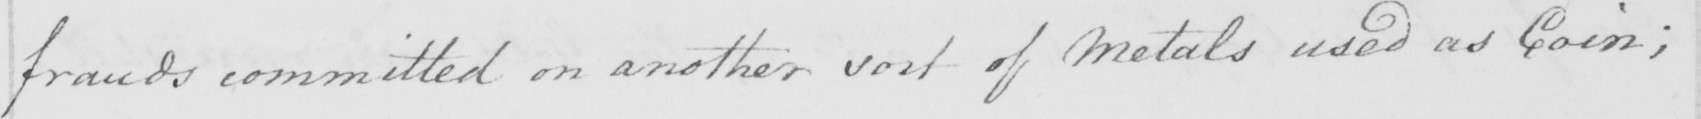Please transcribe the handwritten text in this image. frauds committed on another sort of Metals used as Coin ; 